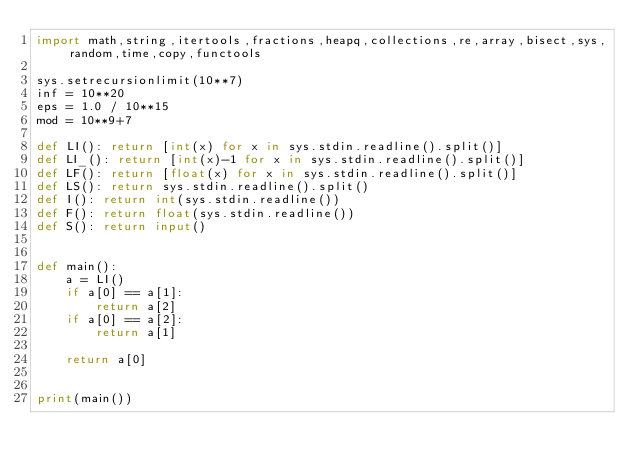Convert code to text. <code><loc_0><loc_0><loc_500><loc_500><_Python_>import math,string,itertools,fractions,heapq,collections,re,array,bisect,sys,random,time,copy,functools

sys.setrecursionlimit(10**7)
inf = 10**20
eps = 1.0 / 10**15
mod = 10**9+7

def LI(): return [int(x) for x in sys.stdin.readline().split()]
def LI_(): return [int(x)-1 for x in sys.stdin.readline().split()]
def LF(): return [float(x) for x in sys.stdin.readline().split()]
def LS(): return sys.stdin.readline().split()
def I(): return int(sys.stdin.readline())
def F(): return float(sys.stdin.readline())
def S(): return input()


def main():
    a = LI()
    if a[0] == a[1]:
        return a[2]
    if a[0] == a[2]:
        return a[1]

    return a[0]


print(main())


</code> 